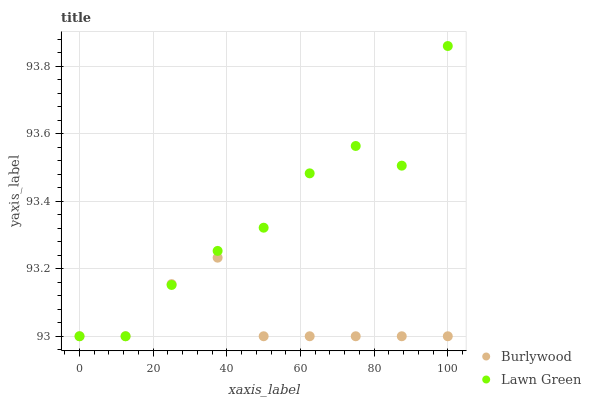Does Burlywood have the minimum area under the curve?
Answer yes or no. Yes. Does Lawn Green have the maximum area under the curve?
Answer yes or no. Yes. Does Lawn Green have the minimum area under the curve?
Answer yes or no. No. Is Burlywood the smoothest?
Answer yes or no. Yes. Is Lawn Green the roughest?
Answer yes or no. Yes. Is Lawn Green the smoothest?
Answer yes or no. No. Does Burlywood have the lowest value?
Answer yes or no. Yes. Does Lawn Green have the highest value?
Answer yes or no. Yes. Does Burlywood intersect Lawn Green?
Answer yes or no. Yes. Is Burlywood less than Lawn Green?
Answer yes or no. No. Is Burlywood greater than Lawn Green?
Answer yes or no. No. 